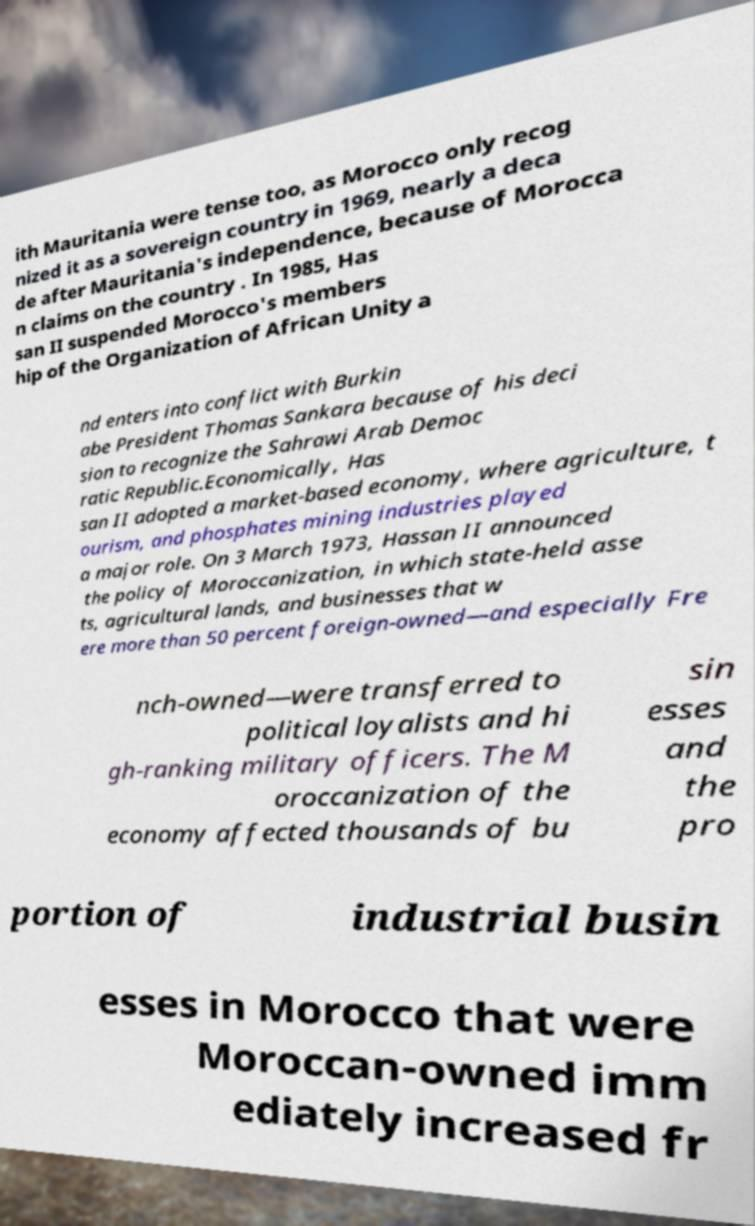There's text embedded in this image that I need extracted. Can you transcribe it verbatim? ith Mauritania were tense too, as Morocco only recog nized it as a sovereign country in 1969, nearly a deca de after Mauritania's independence, because of Morocca n claims on the country . In 1985, Has san II suspended Morocco's members hip of the Organization of African Unity a nd enters into conflict with Burkin abe President Thomas Sankara because of his deci sion to recognize the Sahrawi Arab Democ ratic Republic.Economically, Has san II adopted a market-based economy, where agriculture, t ourism, and phosphates mining industries played a major role. On 3 March 1973, Hassan II announced the policy of Moroccanization, in which state-held asse ts, agricultural lands, and businesses that w ere more than 50 percent foreign-owned—and especially Fre nch-owned—were transferred to political loyalists and hi gh-ranking military officers. The M oroccanization of the economy affected thousands of bu sin esses and the pro portion of industrial busin esses in Morocco that were Moroccan-owned imm ediately increased fr 